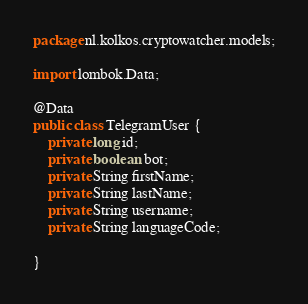<code> <loc_0><loc_0><loc_500><loc_500><_Java_>package nl.kolkos.cryptowatcher.models;

import lombok.Data;

@Data
public class TelegramUser {
    private long id;
    private boolean bot;
    private String firstName;
    private String lastName;
    private String username;
    private String languageCode;

}
</code> 